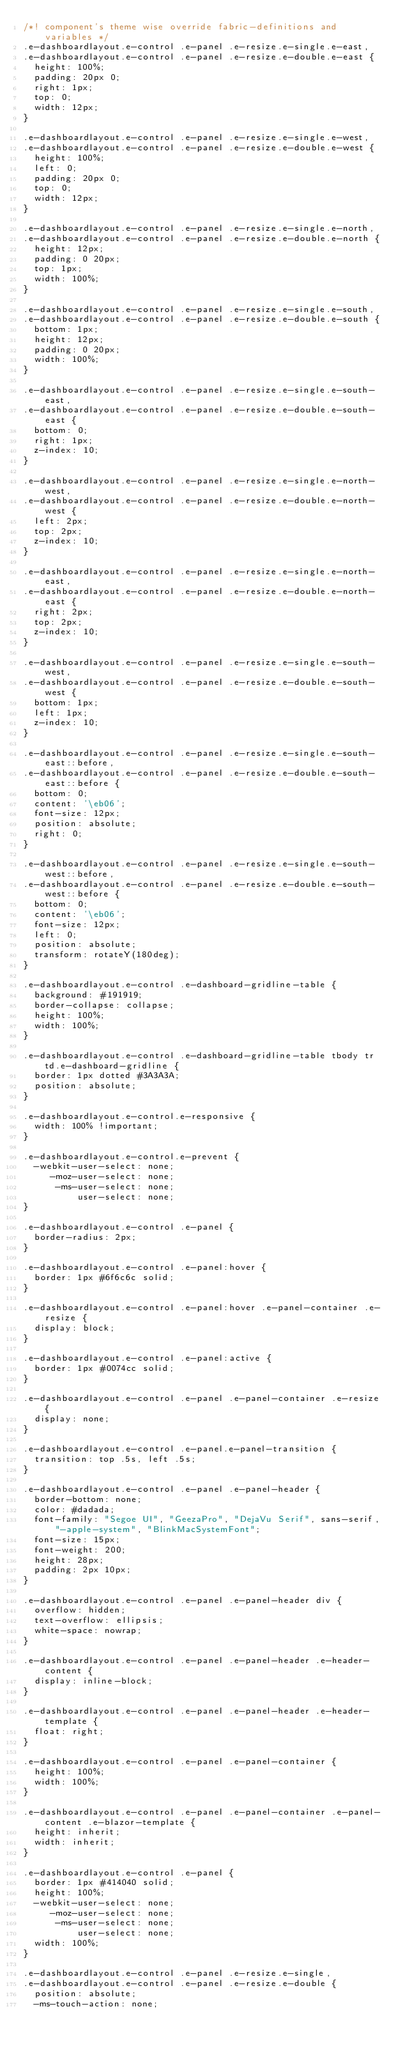Convert code to text. <code><loc_0><loc_0><loc_500><loc_500><_CSS_>/*! component's theme wise override fabric-definitions and variables */
.e-dashboardlayout.e-control .e-panel .e-resize.e-single.e-east,
.e-dashboardlayout.e-control .e-panel .e-resize.e-double.e-east {
  height: 100%;
  padding: 20px 0;
  right: 1px;
  top: 0;
  width: 12px;
}

.e-dashboardlayout.e-control .e-panel .e-resize.e-single.e-west,
.e-dashboardlayout.e-control .e-panel .e-resize.e-double.e-west {
  height: 100%;
  left: 0;
  padding: 20px 0;
  top: 0;
  width: 12px;
}

.e-dashboardlayout.e-control .e-panel .e-resize.e-single.e-north,
.e-dashboardlayout.e-control .e-panel .e-resize.e-double.e-north {
  height: 12px;
  padding: 0 20px;
  top: 1px;
  width: 100%;
}

.e-dashboardlayout.e-control .e-panel .e-resize.e-single.e-south,
.e-dashboardlayout.e-control .e-panel .e-resize.e-double.e-south {
  bottom: 1px;
  height: 12px;
  padding: 0 20px;
  width: 100%;
}

.e-dashboardlayout.e-control .e-panel .e-resize.e-single.e-south-east,
.e-dashboardlayout.e-control .e-panel .e-resize.e-double.e-south-east {
  bottom: 0;
  right: 1px;
  z-index: 10;
}

.e-dashboardlayout.e-control .e-panel .e-resize.e-single.e-north-west,
.e-dashboardlayout.e-control .e-panel .e-resize.e-double.e-north-west {
  left: 2px;
  top: 2px;
  z-index: 10;
}

.e-dashboardlayout.e-control .e-panel .e-resize.e-single.e-north-east,
.e-dashboardlayout.e-control .e-panel .e-resize.e-double.e-north-east {
  right: 2px;
  top: 2px;
  z-index: 10;
}

.e-dashboardlayout.e-control .e-panel .e-resize.e-single.e-south-west,
.e-dashboardlayout.e-control .e-panel .e-resize.e-double.e-south-west {
  bottom: 1px;
  left: 1px;
  z-index: 10;
}

.e-dashboardlayout.e-control .e-panel .e-resize.e-single.e-south-east::before,
.e-dashboardlayout.e-control .e-panel .e-resize.e-double.e-south-east::before {
  bottom: 0;
  content: '\eb06';
  font-size: 12px;
  position: absolute;
  right: 0;
}

.e-dashboardlayout.e-control .e-panel .e-resize.e-single.e-south-west::before,
.e-dashboardlayout.e-control .e-panel .e-resize.e-double.e-south-west::before {
  bottom: 0;
  content: '\eb06';
  font-size: 12px;
  left: 0;
  position: absolute;
  transform: rotateY(180deg);
}

.e-dashboardlayout.e-control .e-dashboard-gridline-table {
  background: #191919;
  border-collapse: collapse;
  height: 100%;
  width: 100%;
}

.e-dashboardlayout.e-control .e-dashboard-gridline-table tbody tr td.e-dashboard-gridline {
  border: 1px dotted #3A3A3A;
  position: absolute;
}

.e-dashboardlayout.e-control.e-responsive {
  width: 100% !important;
}

.e-dashboardlayout.e-control.e-prevent {
  -webkit-user-select: none;
     -moz-user-select: none;
      -ms-user-select: none;
          user-select: none;
}

.e-dashboardlayout.e-control .e-panel {
  border-radius: 2px;
}

.e-dashboardlayout.e-control .e-panel:hover {
  border: 1px #6f6c6c solid;
}

.e-dashboardlayout.e-control .e-panel:hover .e-panel-container .e-resize {
  display: block;
}

.e-dashboardlayout.e-control .e-panel:active {
  border: 1px #0074cc solid;
}

.e-dashboardlayout.e-control .e-panel .e-panel-container .e-resize {
  display: none;
}

.e-dashboardlayout.e-control .e-panel.e-panel-transition {
  transition: top .5s, left .5s;
}

.e-dashboardlayout.e-control .e-panel .e-panel-header {
  border-bottom: none;
  color: #dadada;
  font-family: "Segoe UI", "GeezaPro", "DejaVu Serif", sans-serif, "-apple-system", "BlinkMacSystemFont";
  font-size: 15px;
  font-weight: 200;
  height: 28px;
  padding: 2px 10px;
}

.e-dashboardlayout.e-control .e-panel .e-panel-header div {
  overflow: hidden;
  text-overflow: ellipsis;
  white-space: nowrap;
}

.e-dashboardlayout.e-control .e-panel .e-panel-header .e-header-content {
  display: inline-block;
}

.e-dashboardlayout.e-control .e-panel .e-panel-header .e-header-template {
  float: right;
}

.e-dashboardlayout.e-control .e-panel .e-panel-container {
  height: 100%;
  width: 100%;
}

.e-dashboardlayout.e-control .e-panel .e-panel-container .e-panel-content .e-blazor-template {
  height: inherit;
  width: inherit;
}

.e-dashboardlayout.e-control .e-panel {
  border: 1px #414040 solid;
  height: 100%;
  -webkit-user-select: none;
     -moz-user-select: none;
      -ms-user-select: none;
          user-select: none;
  width: 100%;
}

.e-dashboardlayout.e-control .e-panel .e-resize.e-single,
.e-dashboardlayout.e-control .e-panel .e-resize.e-double {
  position: absolute;
  -ms-touch-action: none;</code> 